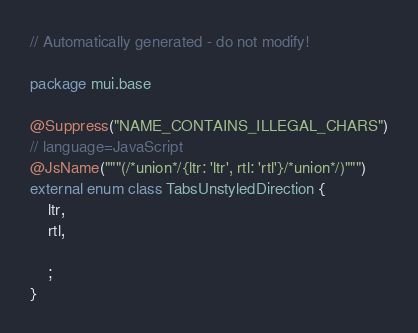<code> <loc_0><loc_0><loc_500><loc_500><_Kotlin_>// Automatically generated - do not modify!

package mui.base

@Suppress("NAME_CONTAINS_ILLEGAL_CHARS")
// language=JavaScript
@JsName("""(/*union*/{ltr: 'ltr', rtl: 'rtl'}/*union*/)""")
external enum class TabsUnstyledDirection {
    ltr,
    rtl,

    ;
}
</code> 